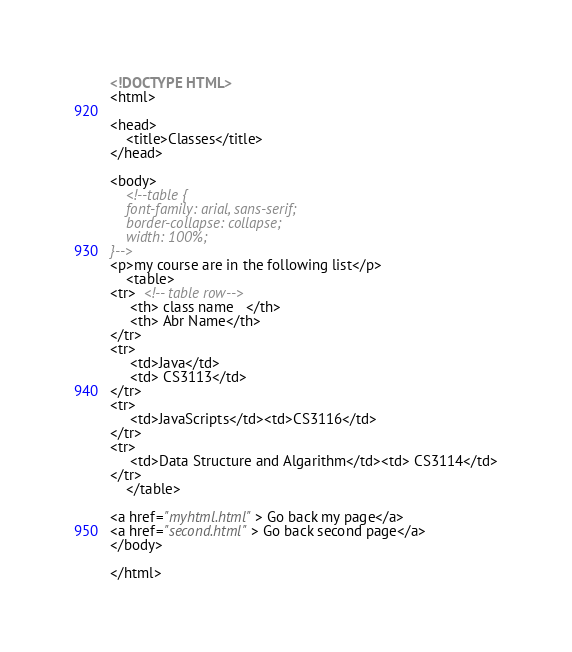Convert code to text. <code><loc_0><loc_0><loc_500><loc_500><_HTML_><!DOCTYPE HTML>
<html>

<head>
    <title>Classes</title>
</head>

<body>
    <!--table {
    font-family: arial, sans-serif;
    border-collapse: collapse;
    width: 100%;
}-->
<p>my course are in the following list</p>
    <table>
<tr>  <!-- table row-->
     <th> class name   </th>
     <th> Abr Name</th>
</tr>
<tr>
     <td>Java</td>
     <td> CS3113</td>
</tr>
<tr>
     <td>JavaScripts</td><td>CS3116</td>
</tr>
<tr>
     <td>Data Structure and Algarithm</td><td> CS3114</td>
</tr>
    </table>

<a href="myhtml.html"> Go back my page</a>
<a href="second.html"> Go back second page</a>
</body>

</html></code> 